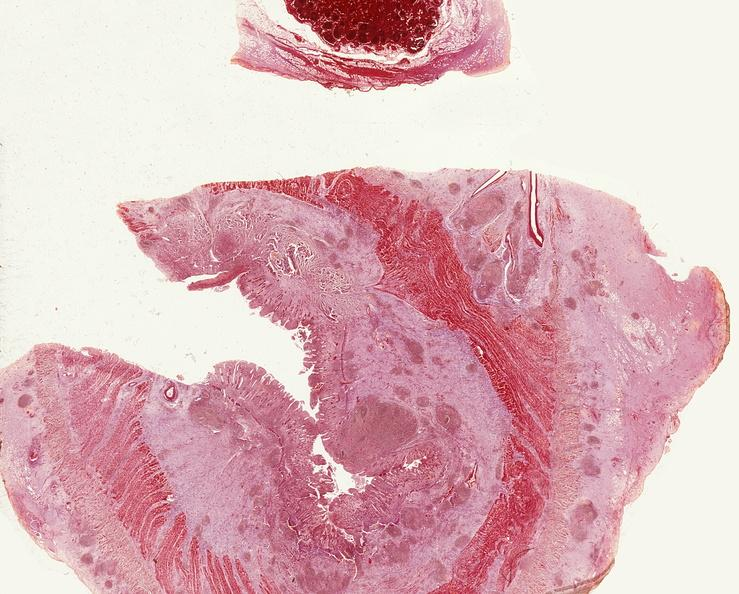does this typical thecoma with yellow foci show small intestine, regional enteritis?
Answer the question using a single word or phrase. No 